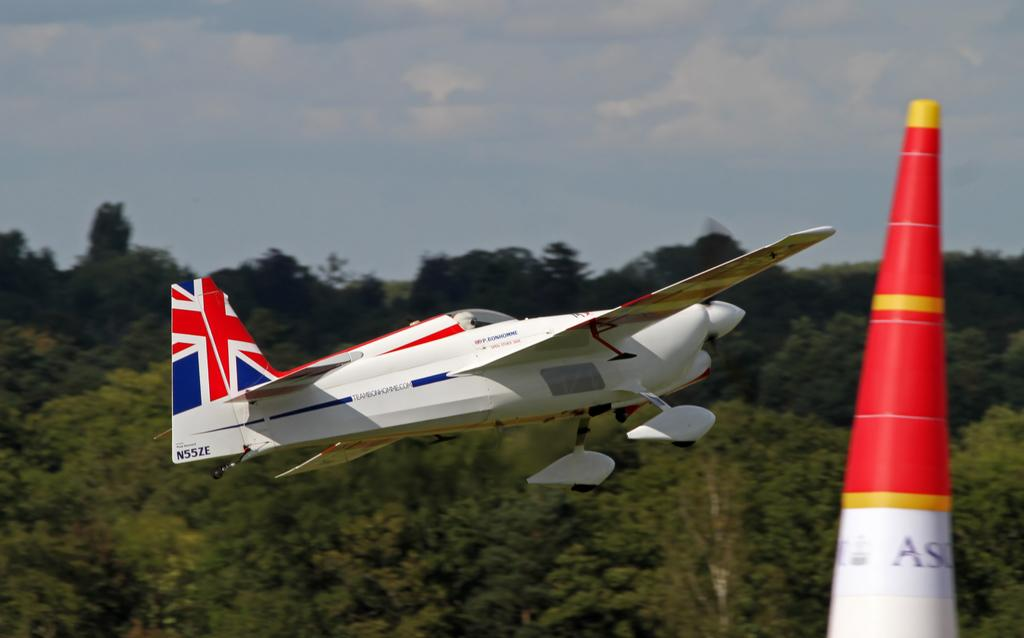What is the main subject of the picture? The main subject of the picture is an aeroplane. What is the aeroplane doing in the picture? The aeroplane is flying in the air. What is the color of the aeroplane? The aeroplane is white in color. What can be seen in the background of the picture? There are trees, the sky, and at least one other object visible in the background of the picture. What type of frame is holding the aeroplane in the picture? There is no frame holding the aeroplane in the picture; it is flying freely in the air. Can you see a tub in the background of the picture? There is no tub present in the background of the picture. 